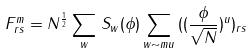Convert formula to latex. <formula><loc_0><loc_0><loc_500><loc_500>F _ { r s } ^ { m } = N ^ { \frac { 1 } { 2 } } \sum _ { w } \, S _ { w } ( \phi ) \sum _ { w \sim m u } \, ( ( \frac { \phi } { \sqrt { N } } ) ^ { u } ) _ { r s }</formula> 